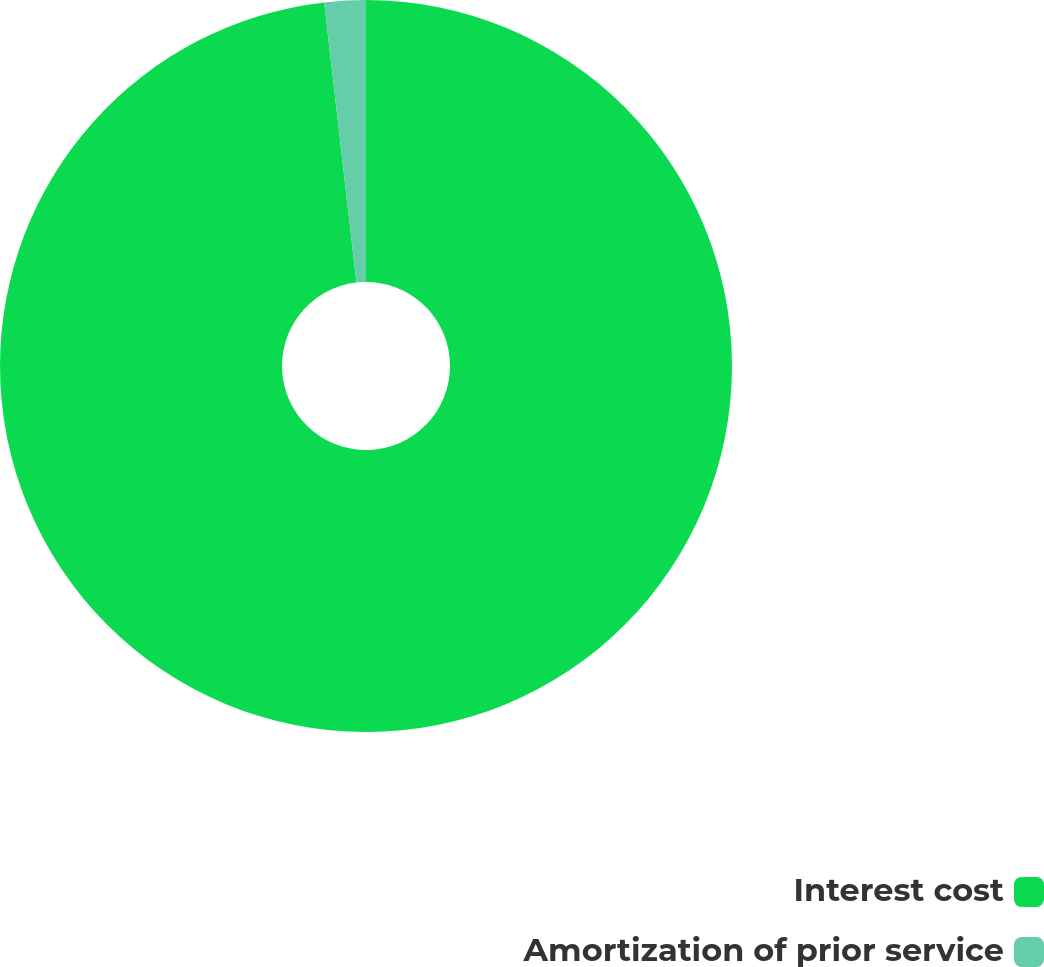Convert chart to OTSL. <chart><loc_0><loc_0><loc_500><loc_500><pie_chart><fcel>Interest cost<fcel>Amortization of prior service<nl><fcel>98.18%<fcel>1.82%<nl></chart> 